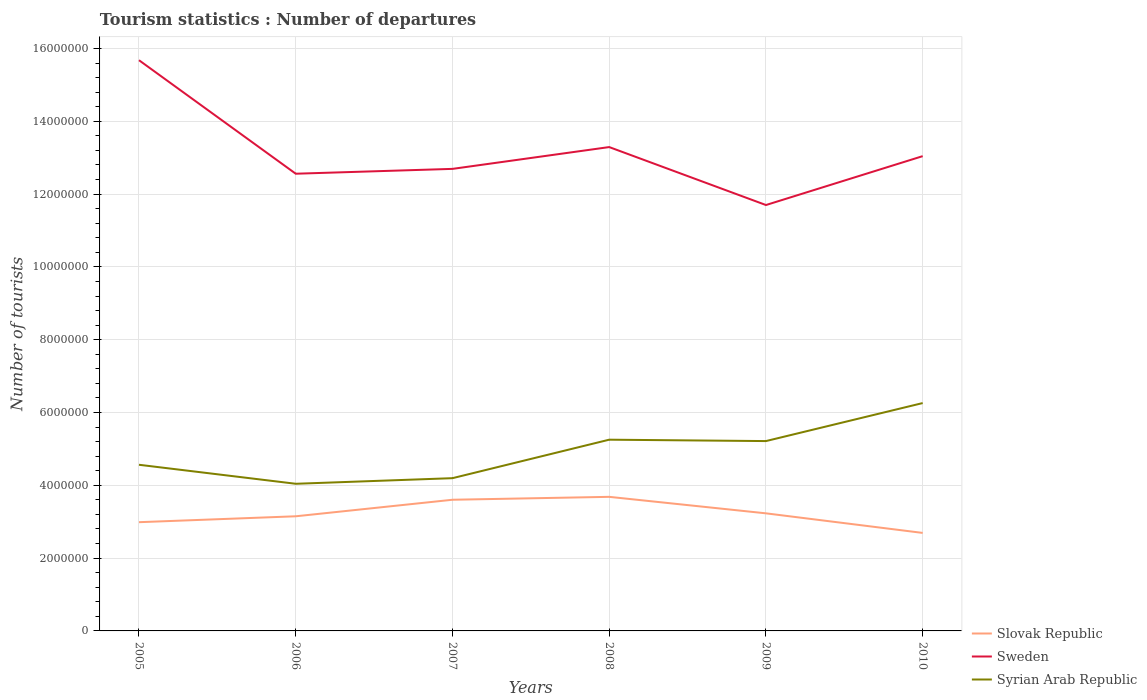How many different coloured lines are there?
Your answer should be very brief. 3. Is the number of lines equal to the number of legend labels?
Provide a succinct answer. Yes. Across all years, what is the maximum number of tourist departures in Sweden?
Ensure brevity in your answer.  1.17e+07. In which year was the number of tourist departures in Syrian Arab Republic maximum?
Offer a terse response. 2006. What is the total number of tourist departures in Sweden in the graph?
Provide a succinct answer. -7.32e+05. What is the difference between the highest and the second highest number of tourist departures in Sweden?
Offer a terse response. 3.98e+06. What is the difference between the highest and the lowest number of tourist departures in Syrian Arab Republic?
Your response must be concise. 3. How many lines are there?
Provide a succinct answer. 3. How many years are there in the graph?
Make the answer very short. 6. What is the difference between two consecutive major ticks on the Y-axis?
Keep it short and to the point. 2.00e+06. Where does the legend appear in the graph?
Ensure brevity in your answer.  Bottom right. How many legend labels are there?
Give a very brief answer. 3. How are the legend labels stacked?
Your response must be concise. Vertical. What is the title of the graph?
Offer a terse response. Tourism statistics : Number of departures. Does "Solomon Islands" appear as one of the legend labels in the graph?
Your answer should be very brief. No. What is the label or title of the X-axis?
Keep it short and to the point. Years. What is the label or title of the Y-axis?
Offer a terse response. Number of tourists. What is the Number of tourists of Slovak Republic in 2005?
Provide a succinct answer. 2.99e+06. What is the Number of tourists in Sweden in 2005?
Provide a short and direct response. 1.57e+07. What is the Number of tourists of Syrian Arab Republic in 2005?
Offer a terse response. 4.56e+06. What is the Number of tourists in Slovak Republic in 2006?
Your answer should be very brief. 3.15e+06. What is the Number of tourists in Sweden in 2006?
Your answer should be very brief. 1.26e+07. What is the Number of tourists of Syrian Arab Republic in 2006?
Provide a short and direct response. 4.04e+06. What is the Number of tourists of Slovak Republic in 2007?
Give a very brief answer. 3.60e+06. What is the Number of tourists in Sweden in 2007?
Make the answer very short. 1.27e+07. What is the Number of tourists in Syrian Arab Republic in 2007?
Your answer should be very brief. 4.20e+06. What is the Number of tourists in Slovak Republic in 2008?
Keep it short and to the point. 3.68e+06. What is the Number of tourists of Sweden in 2008?
Give a very brief answer. 1.33e+07. What is the Number of tourists of Syrian Arab Republic in 2008?
Keep it short and to the point. 5.25e+06. What is the Number of tourists in Slovak Republic in 2009?
Offer a terse response. 3.23e+06. What is the Number of tourists of Sweden in 2009?
Your answer should be very brief. 1.17e+07. What is the Number of tourists of Syrian Arab Republic in 2009?
Ensure brevity in your answer.  5.22e+06. What is the Number of tourists of Slovak Republic in 2010?
Provide a succinct answer. 2.69e+06. What is the Number of tourists of Sweden in 2010?
Keep it short and to the point. 1.30e+07. What is the Number of tourists of Syrian Arab Republic in 2010?
Keep it short and to the point. 6.26e+06. Across all years, what is the maximum Number of tourists in Slovak Republic?
Your answer should be compact. 3.68e+06. Across all years, what is the maximum Number of tourists of Sweden?
Your answer should be very brief. 1.57e+07. Across all years, what is the maximum Number of tourists of Syrian Arab Republic?
Your answer should be compact. 6.26e+06. Across all years, what is the minimum Number of tourists in Slovak Republic?
Your answer should be very brief. 2.69e+06. Across all years, what is the minimum Number of tourists in Sweden?
Ensure brevity in your answer.  1.17e+07. Across all years, what is the minimum Number of tourists in Syrian Arab Republic?
Offer a very short reply. 4.04e+06. What is the total Number of tourists in Slovak Republic in the graph?
Make the answer very short. 1.93e+07. What is the total Number of tourists in Sweden in the graph?
Give a very brief answer. 7.90e+07. What is the total Number of tourists of Syrian Arab Republic in the graph?
Provide a succinct answer. 2.95e+07. What is the difference between the Number of tourists in Slovak Republic in 2005 and that in 2006?
Offer a very short reply. -1.62e+05. What is the difference between the Number of tourists in Sweden in 2005 and that in 2006?
Provide a short and direct response. 3.12e+06. What is the difference between the Number of tourists of Syrian Arab Republic in 2005 and that in 2006?
Ensure brevity in your answer.  5.22e+05. What is the difference between the Number of tourists of Slovak Republic in 2005 and that in 2007?
Keep it short and to the point. -6.16e+05. What is the difference between the Number of tourists in Sweden in 2005 and that in 2007?
Provide a short and direct response. 2.98e+06. What is the difference between the Number of tourists in Syrian Arab Republic in 2005 and that in 2007?
Make the answer very short. 3.68e+05. What is the difference between the Number of tourists in Slovak Republic in 2005 and that in 2008?
Your answer should be very brief. -6.96e+05. What is the difference between the Number of tourists in Sweden in 2005 and that in 2008?
Your answer should be very brief. 2.39e+06. What is the difference between the Number of tourists of Syrian Arab Republic in 2005 and that in 2008?
Keep it short and to the point. -6.89e+05. What is the difference between the Number of tourists of Slovak Republic in 2005 and that in 2009?
Give a very brief answer. -2.43e+05. What is the difference between the Number of tourists of Sweden in 2005 and that in 2009?
Offer a terse response. 3.98e+06. What is the difference between the Number of tourists of Syrian Arab Republic in 2005 and that in 2009?
Your answer should be very brief. -6.51e+05. What is the difference between the Number of tourists in Slovak Republic in 2005 and that in 2010?
Your response must be concise. 2.95e+05. What is the difference between the Number of tourists in Sweden in 2005 and that in 2010?
Your response must be concise. 2.64e+06. What is the difference between the Number of tourists of Syrian Arab Republic in 2005 and that in 2010?
Keep it short and to the point. -1.70e+06. What is the difference between the Number of tourists of Slovak Republic in 2006 and that in 2007?
Keep it short and to the point. -4.54e+05. What is the difference between the Number of tourists in Sweden in 2006 and that in 2007?
Your answer should be compact. -1.33e+05. What is the difference between the Number of tourists in Syrian Arab Republic in 2006 and that in 2007?
Offer a very short reply. -1.54e+05. What is the difference between the Number of tourists in Slovak Republic in 2006 and that in 2008?
Give a very brief answer. -5.34e+05. What is the difference between the Number of tourists of Sweden in 2006 and that in 2008?
Your response must be concise. -7.32e+05. What is the difference between the Number of tourists in Syrian Arab Republic in 2006 and that in 2008?
Your response must be concise. -1.21e+06. What is the difference between the Number of tourists in Slovak Republic in 2006 and that in 2009?
Your answer should be compact. -8.10e+04. What is the difference between the Number of tourists in Sweden in 2006 and that in 2009?
Give a very brief answer. 8.60e+05. What is the difference between the Number of tourists in Syrian Arab Republic in 2006 and that in 2009?
Your answer should be compact. -1.17e+06. What is the difference between the Number of tourists of Slovak Republic in 2006 and that in 2010?
Keep it short and to the point. 4.57e+05. What is the difference between the Number of tourists in Sweden in 2006 and that in 2010?
Your response must be concise. -4.83e+05. What is the difference between the Number of tourists in Syrian Arab Republic in 2006 and that in 2010?
Ensure brevity in your answer.  -2.22e+06. What is the difference between the Number of tourists of Slovak Republic in 2007 and that in 2008?
Make the answer very short. -8.00e+04. What is the difference between the Number of tourists in Sweden in 2007 and that in 2008?
Give a very brief answer. -5.99e+05. What is the difference between the Number of tourists of Syrian Arab Republic in 2007 and that in 2008?
Give a very brief answer. -1.06e+06. What is the difference between the Number of tourists in Slovak Republic in 2007 and that in 2009?
Offer a terse response. 3.73e+05. What is the difference between the Number of tourists in Sweden in 2007 and that in 2009?
Offer a very short reply. 9.93e+05. What is the difference between the Number of tourists of Syrian Arab Republic in 2007 and that in 2009?
Keep it short and to the point. -1.02e+06. What is the difference between the Number of tourists of Slovak Republic in 2007 and that in 2010?
Ensure brevity in your answer.  9.11e+05. What is the difference between the Number of tourists of Sweden in 2007 and that in 2010?
Your answer should be compact. -3.50e+05. What is the difference between the Number of tourists in Syrian Arab Republic in 2007 and that in 2010?
Give a very brief answer. -2.06e+06. What is the difference between the Number of tourists of Slovak Republic in 2008 and that in 2009?
Make the answer very short. 4.53e+05. What is the difference between the Number of tourists of Sweden in 2008 and that in 2009?
Give a very brief answer. 1.59e+06. What is the difference between the Number of tourists in Syrian Arab Republic in 2008 and that in 2009?
Provide a succinct answer. 3.80e+04. What is the difference between the Number of tourists of Slovak Republic in 2008 and that in 2010?
Offer a terse response. 9.91e+05. What is the difference between the Number of tourists in Sweden in 2008 and that in 2010?
Keep it short and to the point. 2.49e+05. What is the difference between the Number of tourists of Syrian Arab Republic in 2008 and that in 2010?
Offer a very short reply. -1.01e+06. What is the difference between the Number of tourists in Slovak Republic in 2009 and that in 2010?
Provide a short and direct response. 5.38e+05. What is the difference between the Number of tourists in Sweden in 2009 and that in 2010?
Keep it short and to the point. -1.34e+06. What is the difference between the Number of tourists in Syrian Arab Republic in 2009 and that in 2010?
Make the answer very short. -1.04e+06. What is the difference between the Number of tourists of Slovak Republic in 2005 and the Number of tourists of Sweden in 2006?
Your response must be concise. -9.57e+06. What is the difference between the Number of tourists in Slovak Republic in 2005 and the Number of tourists in Syrian Arab Republic in 2006?
Offer a terse response. -1.06e+06. What is the difference between the Number of tourists in Sweden in 2005 and the Number of tourists in Syrian Arab Republic in 2006?
Offer a very short reply. 1.16e+07. What is the difference between the Number of tourists of Slovak Republic in 2005 and the Number of tourists of Sweden in 2007?
Provide a short and direct response. -9.70e+06. What is the difference between the Number of tourists in Slovak Republic in 2005 and the Number of tourists in Syrian Arab Republic in 2007?
Your answer should be compact. -1.21e+06. What is the difference between the Number of tourists of Sweden in 2005 and the Number of tourists of Syrian Arab Republic in 2007?
Your response must be concise. 1.15e+07. What is the difference between the Number of tourists in Slovak Republic in 2005 and the Number of tourists in Sweden in 2008?
Offer a very short reply. -1.03e+07. What is the difference between the Number of tourists of Slovak Republic in 2005 and the Number of tourists of Syrian Arab Republic in 2008?
Your response must be concise. -2.27e+06. What is the difference between the Number of tourists in Sweden in 2005 and the Number of tourists in Syrian Arab Republic in 2008?
Provide a short and direct response. 1.04e+07. What is the difference between the Number of tourists in Slovak Republic in 2005 and the Number of tourists in Sweden in 2009?
Keep it short and to the point. -8.71e+06. What is the difference between the Number of tourists of Slovak Republic in 2005 and the Number of tourists of Syrian Arab Republic in 2009?
Your answer should be very brief. -2.23e+06. What is the difference between the Number of tourists of Sweden in 2005 and the Number of tourists of Syrian Arab Republic in 2009?
Provide a succinct answer. 1.05e+07. What is the difference between the Number of tourists in Slovak Republic in 2005 and the Number of tourists in Sweden in 2010?
Ensure brevity in your answer.  -1.01e+07. What is the difference between the Number of tourists in Slovak Republic in 2005 and the Number of tourists in Syrian Arab Republic in 2010?
Keep it short and to the point. -3.27e+06. What is the difference between the Number of tourists of Sweden in 2005 and the Number of tourists of Syrian Arab Republic in 2010?
Your response must be concise. 9.42e+06. What is the difference between the Number of tourists of Slovak Republic in 2006 and the Number of tourists of Sweden in 2007?
Ensure brevity in your answer.  -9.54e+06. What is the difference between the Number of tourists of Slovak Republic in 2006 and the Number of tourists of Syrian Arab Republic in 2007?
Offer a terse response. -1.05e+06. What is the difference between the Number of tourists of Sweden in 2006 and the Number of tourists of Syrian Arab Republic in 2007?
Keep it short and to the point. 8.36e+06. What is the difference between the Number of tourists of Slovak Republic in 2006 and the Number of tourists of Sweden in 2008?
Offer a terse response. -1.01e+07. What is the difference between the Number of tourists of Slovak Republic in 2006 and the Number of tourists of Syrian Arab Republic in 2008?
Offer a very short reply. -2.10e+06. What is the difference between the Number of tourists in Sweden in 2006 and the Number of tourists in Syrian Arab Republic in 2008?
Provide a short and direct response. 7.31e+06. What is the difference between the Number of tourists of Slovak Republic in 2006 and the Number of tourists of Sweden in 2009?
Provide a succinct answer. -8.55e+06. What is the difference between the Number of tourists in Slovak Republic in 2006 and the Number of tourists in Syrian Arab Republic in 2009?
Keep it short and to the point. -2.07e+06. What is the difference between the Number of tourists of Sweden in 2006 and the Number of tourists of Syrian Arab Republic in 2009?
Provide a short and direct response. 7.34e+06. What is the difference between the Number of tourists of Slovak Republic in 2006 and the Number of tourists of Sweden in 2010?
Your response must be concise. -9.89e+06. What is the difference between the Number of tourists in Slovak Republic in 2006 and the Number of tourists in Syrian Arab Republic in 2010?
Provide a short and direct response. -3.11e+06. What is the difference between the Number of tourists in Sweden in 2006 and the Number of tourists in Syrian Arab Republic in 2010?
Your answer should be very brief. 6.30e+06. What is the difference between the Number of tourists of Slovak Republic in 2007 and the Number of tourists of Sweden in 2008?
Keep it short and to the point. -9.69e+06. What is the difference between the Number of tourists of Slovak Republic in 2007 and the Number of tourists of Syrian Arab Republic in 2008?
Offer a very short reply. -1.65e+06. What is the difference between the Number of tourists in Sweden in 2007 and the Number of tourists in Syrian Arab Republic in 2008?
Keep it short and to the point. 7.44e+06. What is the difference between the Number of tourists of Slovak Republic in 2007 and the Number of tourists of Sweden in 2009?
Your answer should be very brief. -8.10e+06. What is the difference between the Number of tourists of Slovak Republic in 2007 and the Number of tourists of Syrian Arab Republic in 2009?
Offer a very short reply. -1.61e+06. What is the difference between the Number of tourists of Sweden in 2007 and the Number of tourists of Syrian Arab Republic in 2009?
Offer a very short reply. 7.48e+06. What is the difference between the Number of tourists of Slovak Republic in 2007 and the Number of tourists of Sweden in 2010?
Keep it short and to the point. -9.44e+06. What is the difference between the Number of tourists of Slovak Republic in 2007 and the Number of tourists of Syrian Arab Republic in 2010?
Offer a very short reply. -2.66e+06. What is the difference between the Number of tourists in Sweden in 2007 and the Number of tourists in Syrian Arab Republic in 2010?
Offer a terse response. 6.43e+06. What is the difference between the Number of tourists in Slovak Republic in 2008 and the Number of tourists in Sweden in 2009?
Your response must be concise. -8.02e+06. What is the difference between the Number of tourists of Slovak Republic in 2008 and the Number of tourists of Syrian Arab Republic in 2009?
Make the answer very short. -1.53e+06. What is the difference between the Number of tourists of Sweden in 2008 and the Number of tourists of Syrian Arab Republic in 2009?
Ensure brevity in your answer.  8.08e+06. What is the difference between the Number of tourists in Slovak Republic in 2008 and the Number of tourists in Sweden in 2010?
Your answer should be very brief. -9.36e+06. What is the difference between the Number of tourists of Slovak Republic in 2008 and the Number of tourists of Syrian Arab Republic in 2010?
Your answer should be very brief. -2.58e+06. What is the difference between the Number of tourists of Sweden in 2008 and the Number of tourists of Syrian Arab Republic in 2010?
Offer a very short reply. 7.03e+06. What is the difference between the Number of tourists of Slovak Republic in 2009 and the Number of tourists of Sweden in 2010?
Provide a succinct answer. -9.81e+06. What is the difference between the Number of tourists of Slovak Republic in 2009 and the Number of tourists of Syrian Arab Republic in 2010?
Keep it short and to the point. -3.03e+06. What is the difference between the Number of tourists of Sweden in 2009 and the Number of tourists of Syrian Arab Republic in 2010?
Your answer should be very brief. 5.44e+06. What is the average Number of tourists in Slovak Republic per year?
Provide a short and direct response. 3.22e+06. What is the average Number of tourists of Sweden per year?
Give a very brief answer. 1.32e+07. What is the average Number of tourists of Syrian Arab Republic per year?
Keep it short and to the point. 4.92e+06. In the year 2005, what is the difference between the Number of tourists in Slovak Republic and Number of tourists in Sweden?
Ensure brevity in your answer.  -1.27e+07. In the year 2005, what is the difference between the Number of tourists in Slovak Republic and Number of tourists in Syrian Arab Republic?
Give a very brief answer. -1.58e+06. In the year 2005, what is the difference between the Number of tourists of Sweden and Number of tourists of Syrian Arab Republic?
Your answer should be very brief. 1.11e+07. In the year 2006, what is the difference between the Number of tourists of Slovak Republic and Number of tourists of Sweden?
Offer a very short reply. -9.41e+06. In the year 2006, what is the difference between the Number of tourists of Slovak Republic and Number of tourists of Syrian Arab Republic?
Ensure brevity in your answer.  -8.93e+05. In the year 2006, what is the difference between the Number of tourists in Sweden and Number of tourists in Syrian Arab Republic?
Keep it short and to the point. 8.52e+06. In the year 2007, what is the difference between the Number of tourists in Slovak Republic and Number of tourists in Sweden?
Ensure brevity in your answer.  -9.09e+06. In the year 2007, what is the difference between the Number of tourists in Slovak Republic and Number of tourists in Syrian Arab Republic?
Provide a succinct answer. -5.93e+05. In the year 2007, what is the difference between the Number of tourists of Sweden and Number of tourists of Syrian Arab Republic?
Offer a very short reply. 8.50e+06. In the year 2008, what is the difference between the Number of tourists in Slovak Republic and Number of tourists in Sweden?
Give a very brief answer. -9.61e+06. In the year 2008, what is the difference between the Number of tourists of Slovak Republic and Number of tourists of Syrian Arab Republic?
Your answer should be compact. -1.57e+06. In the year 2008, what is the difference between the Number of tourists in Sweden and Number of tourists in Syrian Arab Republic?
Give a very brief answer. 8.04e+06. In the year 2009, what is the difference between the Number of tourists in Slovak Republic and Number of tourists in Sweden?
Your answer should be very brief. -8.47e+06. In the year 2009, what is the difference between the Number of tourists of Slovak Republic and Number of tourists of Syrian Arab Republic?
Your response must be concise. -1.98e+06. In the year 2009, what is the difference between the Number of tourists of Sweden and Number of tourists of Syrian Arab Republic?
Keep it short and to the point. 6.48e+06. In the year 2010, what is the difference between the Number of tourists of Slovak Republic and Number of tourists of Sweden?
Provide a short and direct response. -1.04e+07. In the year 2010, what is the difference between the Number of tourists of Slovak Republic and Number of tourists of Syrian Arab Republic?
Your answer should be very brief. -3.57e+06. In the year 2010, what is the difference between the Number of tourists in Sweden and Number of tourists in Syrian Arab Republic?
Offer a terse response. 6.78e+06. What is the ratio of the Number of tourists in Slovak Republic in 2005 to that in 2006?
Provide a short and direct response. 0.95. What is the ratio of the Number of tourists in Sweden in 2005 to that in 2006?
Provide a succinct answer. 1.25. What is the ratio of the Number of tourists of Syrian Arab Republic in 2005 to that in 2006?
Provide a short and direct response. 1.13. What is the ratio of the Number of tourists of Slovak Republic in 2005 to that in 2007?
Make the answer very short. 0.83. What is the ratio of the Number of tourists of Sweden in 2005 to that in 2007?
Provide a succinct answer. 1.24. What is the ratio of the Number of tourists of Syrian Arab Republic in 2005 to that in 2007?
Make the answer very short. 1.09. What is the ratio of the Number of tourists of Slovak Republic in 2005 to that in 2008?
Your answer should be very brief. 0.81. What is the ratio of the Number of tourists of Sweden in 2005 to that in 2008?
Your answer should be very brief. 1.18. What is the ratio of the Number of tourists of Syrian Arab Republic in 2005 to that in 2008?
Your answer should be compact. 0.87. What is the ratio of the Number of tourists of Slovak Republic in 2005 to that in 2009?
Offer a very short reply. 0.92. What is the ratio of the Number of tourists of Sweden in 2005 to that in 2009?
Your answer should be compact. 1.34. What is the ratio of the Number of tourists of Syrian Arab Republic in 2005 to that in 2009?
Offer a very short reply. 0.88. What is the ratio of the Number of tourists of Slovak Republic in 2005 to that in 2010?
Give a very brief answer. 1.11. What is the ratio of the Number of tourists of Sweden in 2005 to that in 2010?
Offer a terse response. 1.2. What is the ratio of the Number of tourists of Syrian Arab Republic in 2005 to that in 2010?
Keep it short and to the point. 0.73. What is the ratio of the Number of tourists of Slovak Republic in 2006 to that in 2007?
Your answer should be very brief. 0.87. What is the ratio of the Number of tourists in Sweden in 2006 to that in 2007?
Offer a very short reply. 0.99. What is the ratio of the Number of tourists of Syrian Arab Republic in 2006 to that in 2007?
Offer a very short reply. 0.96. What is the ratio of the Number of tourists of Slovak Republic in 2006 to that in 2008?
Make the answer very short. 0.85. What is the ratio of the Number of tourists of Sweden in 2006 to that in 2008?
Offer a terse response. 0.94. What is the ratio of the Number of tourists in Syrian Arab Republic in 2006 to that in 2008?
Provide a succinct answer. 0.77. What is the ratio of the Number of tourists in Slovak Republic in 2006 to that in 2009?
Offer a very short reply. 0.97. What is the ratio of the Number of tourists of Sweden in 2006 to that in 2009?
Your response must be concise. 1.07. What is the ratio of the Number of tourists of Syrian Arab Republic in 2006 to that in 2009?
Keep it short and to the point. 0.78. What is the ratio of the Number of tourists of Slovak Republic in 2006 to that in 2010?
Keep it short and to the point. 1.17. What is the ratio of the Number of tourists of Syrian Arab Republic in 2006 to that in 2010?
Provide a succinct answer. 0.65. What is the ratio of the Number of tourists of Slovak Republic in 2007 to that in 2008?
Make the answer very short. 0.98. What is the ratio of the Number of tourists of Sweden in 2007 to that in 2008?
Your response must be concise. 0.95. What is the ratio of the Number of tourists in Syrian Arab Republic in 2007 to that in 2008?
Provide a succinct answer. 0.8. What is the ratio of the Number of tourists in Slovak Republic in 2007 to that in 2009?
Make the answer very short. 1.12. What is the ratio of the Number of tourists in Sweden in 2007 to that in 2009?
Your response must be concise. 1.08. What is the ratio of the Number of tourists of Syrian Arab Republic in 2007 to that in 2009?
Provide a short and direct response. 0.8. What is the ratio of the Number of tourists in Slovak Republic in 2007 to that in 2010?
Provide a short and direct response. 1.34. What is the ratio of the Number of tourists in Sweden in 2007 to that in 2010?
Provide a succinct answer. 0.97. What is the ratio of the Number of tourists in Syrian Arab Republic in 2007 to that in 2010?
Give a very brief answer. 0.67. What is the ratio of the Number of tourists of Slovak Republic in 2008 to that in 2009?
Your answer should be compact. 1.14. What is the ratio of the Number of tourists of Sweden in 2008 to that in 2009?
Give a very brief answer. 1.14. What is the ratio of the Number of tourists of Syrian Arab Republic in 2008 to that in 2009?
Your response must be concise. 1.01. What is the ratio of the Number of tourists in Slovak Republic in 2008 to that in 2010?
Provide a succinct answer. 1.37. What is the ratio of the Number of tourists in Sweden in 2008 to that in 2010?
Your answer should be compact. 1.02. What is the ratio of the Number of tourists of Syrian Arab Republic in 2008 to that in 2010?
Your answer should be very brief. 0.84. What is the ratio of the Number of tourists of Slovak Republic in 2009 to that in 2010?
Your response must be concise. 1.2. What is the ratio of the Number of tourists in Sweden in 2009 to that in 2010?
Provide a short and direct response. 0.9. What is the ratio of the Number of tourists of Syrian Arab Republic in 2009 to that in 2010?
Provide a short and direct response. 0.83. What is the difference between the highest and the second highest Number of tourists of Slovak Republic?
Your answer should be very brief. 8.00e+04. What is the difference between the highest and the second highest Number of tourists in Sweden?
Make the answer very short. 2.39e+06. What is the difference between the highest and the second highest Number of tourists in Syrian Arab Republic?
Provide a short and direct response. 1.01e+06. What is the difference between the highest and the lowest Number of tourists of Slovak Republic?
Your answer should be compact. 9.91e+05. What is the difference between the highest and the lowest Number of tourists in Sweden?
Provide a short and direct response. 3.98e+06. What is the difference between the highest and the lowest Number of tourists in Syrian Arab Republic?
Your response must be concise. 2.22e+06. 